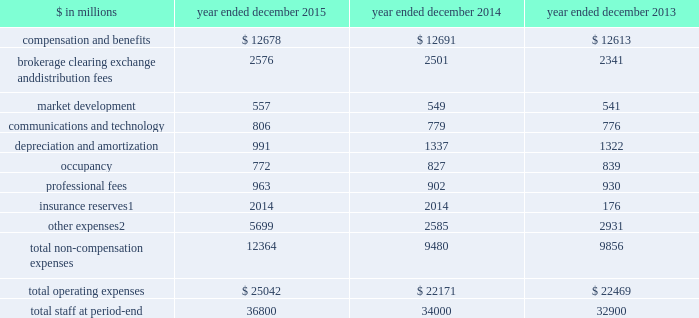The goldman sachs group , inc .
And subsidiaries management 2019s discussion and analysis operating expenses our operating expenses are primarily influenced by compensation , headcount and levels of business activity .
Compensation and benefits includes salaries , discretionary compensation , amortization of equity awards and other items such as benefits .
Discretionary compensation is significantly impacted by , among other factors , the level of net revenues , overall financial performance , prevailing labor markets , business mix , the structure of our share- based compensation programs and the external environment .
In addition , see 201cuse of estimates 201d for additional information about expenses that may arise from litigation and regulatory proceedings .
The table below presents our operating expenses and total staff ( which includes employees , consultants and temporary staff ) . .
Consists of changes in reserves related to our americas reinsurance business , including interest credited to policyholder account balances , and expenses related to property catastrophe reinsurance claims .
In april 2013 , we completed the sale of a majority stake in our americas reinsurance business and no longer consolidate this business .
Includes provisions of $ 3.37 billion recorded during 2015 for the agreement in principle with the rmbs working group .
See note 27 to the consolidated financial statements for further information about this agreement in principle .
2015 versus 2014 .
Operating expenses on the consolidated statements of earnings were $ 25.04 billion for 2015 , 13% ( 13 % ) higher than 2014 .
Compensation and benefits expenses on the consolidated statements of earnings were $ 12.68 billion for 2015 , essentially unchanged compared with 2014 .
The ratio of compensation and benefits to net revenues for 2015 was 37.5% ( 37.5 % ) compared with 36.8% ( 36.8 % ) for 2014 .
Total staff increased 8% ( 8 % ) during 2015 , primarily due to activity levels in certain businesses and continued investment in regulatory compliance .
Non-compensation expenses on the consolidated statements of earnings were $ 12.36 billion for 2015 , 30% ( 30 % ) higher than 2014 , due to significantly higher net provisions for mortgage-related litigation and regulatory matters , which are included in other expenses .
This increase was partially offset by lower depreciation and amortization expenses , primarily reflecting lower impairment charges related to consolidated investments , and a reduction in expenses related to the sale of metro in the fourth quarter of 2014 .
Net provisions for litigation and regulatory proceedings for 2015 were $ 4.01 billion compared with $ 754 million for 2014 ( both primarily comprised of net provisions for mortgage-related matters ) .
2015 included a $ 148 million charitable contribution to goldman sachs gives , our donor-advised fund .
Compensation was reduced to fund this charitable contribution to goldman sachs gives .
The firm asks its participating managing directors to make recommendations regarding potential charitable recipients for this contribution .
2014 versus 2013 .
Operating expenses on the consolidated statements of earnings were $ 22.17 billion for 2014 , essentially unchanged compared with 2013 .
Compensation and benefits expenses on the consolidated statements of earnings were $ 12.69 billion for 2014 , essentially unchanged compared with 2013 .
The ratio of compensation and benefits to net revenues for 2014 was 36.8% ( 36.8 % ) compared with 36.9% ( 36.9 % ) for 2013 .
Total staff increased 3% ( 3 % ) during 2014 .
Non-compensation expenses on the consolidated statements of earnings were $ 9.48 billion for 2014 , 4% ( 4 % ) lower than 2013 .
The decrease compared with 2013 included a decrease in other expenses , due to lower net provisions for litigation and regulatory proceedings and lower operating expenses related to consolidated investments , as well as a decline in insurance reserves , reflecting the sale of our americas reinsurance business in 2013 .
These decreases were partially offset by an increase in brokerage , clearing , exchange and distribution fees .
Net provisions for litigation and regulatory proceedings for 2014 were $ 754 million compared with $ 962 million for 2013 ( both primarily comprised of net provisions for mortgage-related matters ) .
2014 included a charitable contribution of $ 137 million to goldman sachs gives , our donor-advised fund .
Compensation was reduced to fund this charitable contribution to goldman sachs gives .
The firm asks its participating managing directors to make recommendations regarding potential charitable recipients for this contribution .
58 goldman sachs 2015 form 10-k .
What the average compensation and benefits per head count in 2015? 
Computations: ((12678 * 1000000) / 36800)
Answer: 344510.86957. 